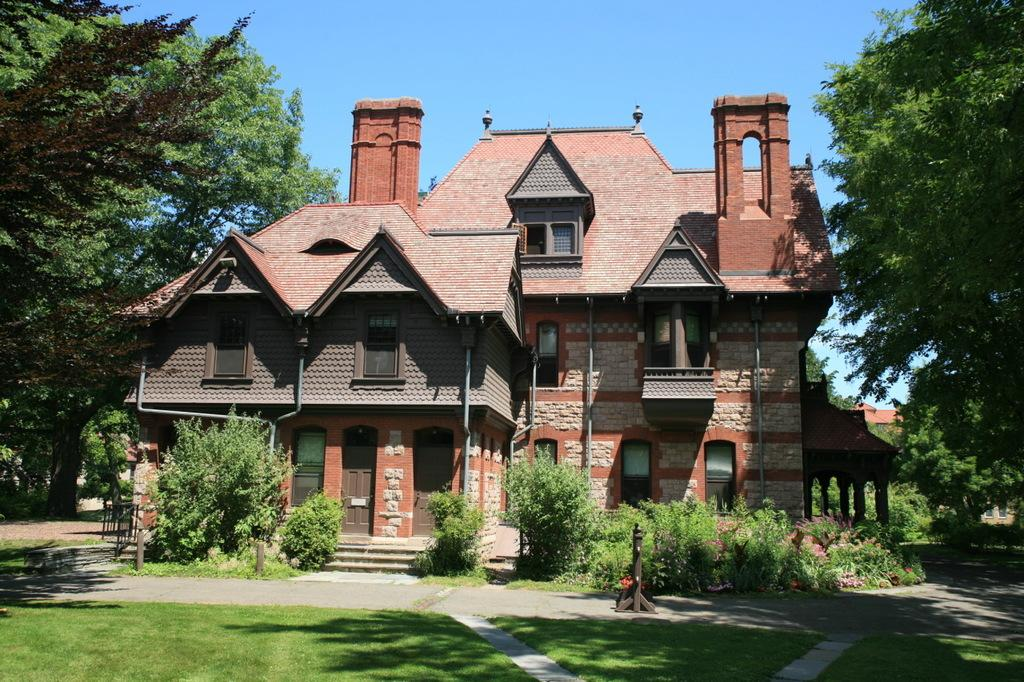What type of structures can be seen in the image? There are houses in the image. What is located in front of the houses? Metal rods are present in front of the houses. What type of vegetation is visible in the image? Plants and trees are present in the image. What can be seen attached to the walls of the houses? Pipes are attached to the walls of the houses. How does the feeling of shame manifest in the image? There is no indication of shame or any emotional state in the image; it only shows houses, metal rods, plants, trees, and pipes. 